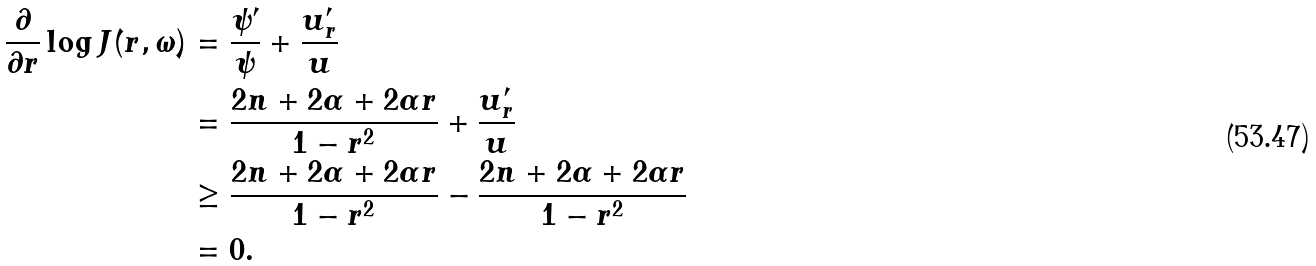<formula> <loc_0><loc_0><loc_500><loc_500>\frac { \partial } { \partial r } \log J ( r , \omega ) & = \frac { \psi ^ { \prime } } { \psi } + \frac { u ^ { \prime } _ { r } } { u } \\ & = \frac { 2 n + 2 \alpha + 2 \alpha r } { 1 - r ^ { 2 } } + \frac { u ^ { \prime } _ { r } } { u } \\ & \geq \frac { 2 n + 2 \alpha + 2 \alpha r } { 1 - r ^ { 2 } } - \frac { 2 n + 2 \alpha + 2 \alpha r } { 1 - r ^ { 2 } } \\ & = 0 .</formula> 